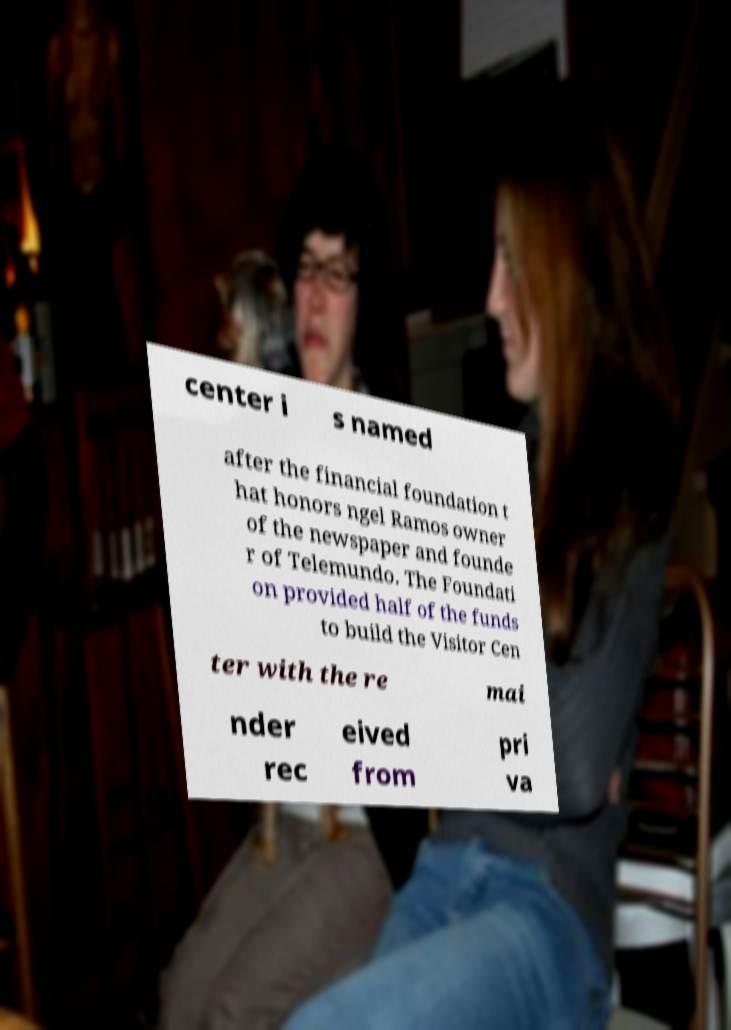Please read and relay the text visible in this image. What does it say? center i s named after the financial foundation t hat honors ngel Ramos owner of the newspaper and founde r of Telemundo. The Foundati on provided half of the funds to build the Visitor Cen ter with the re mai nder rec eived from pri va 